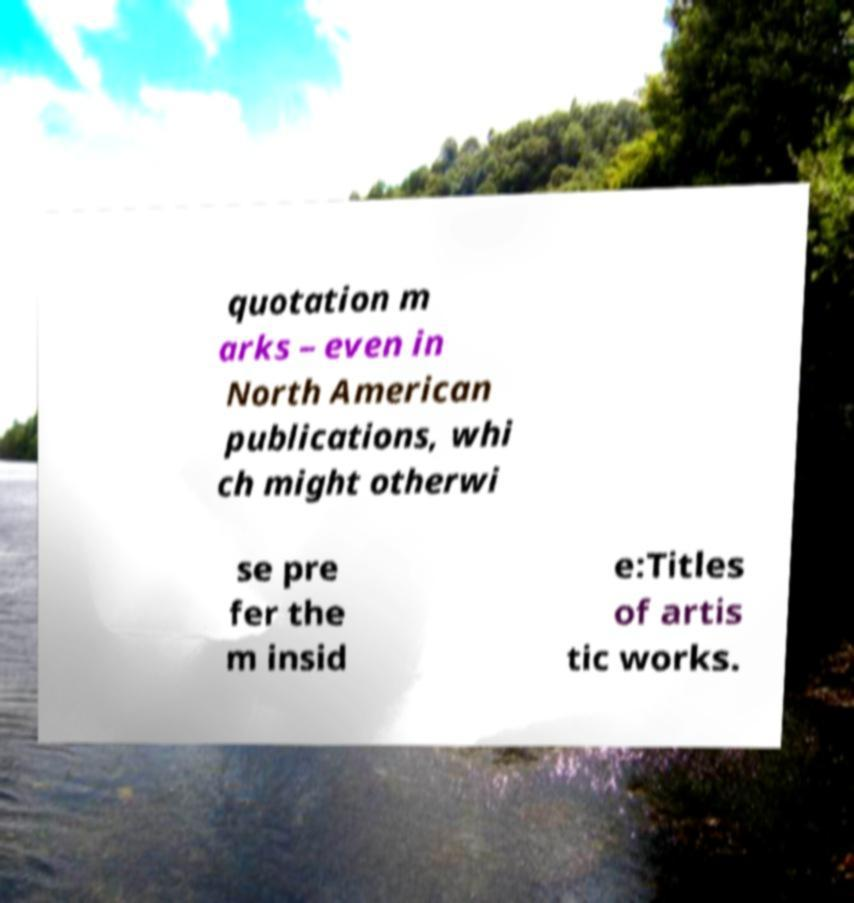I need the written content from this picture converted into text. Can you do that? quotation m arks – even in North American publications, whi ch might otherwi se pre fer the m insid e:Titles of artis tic works. 